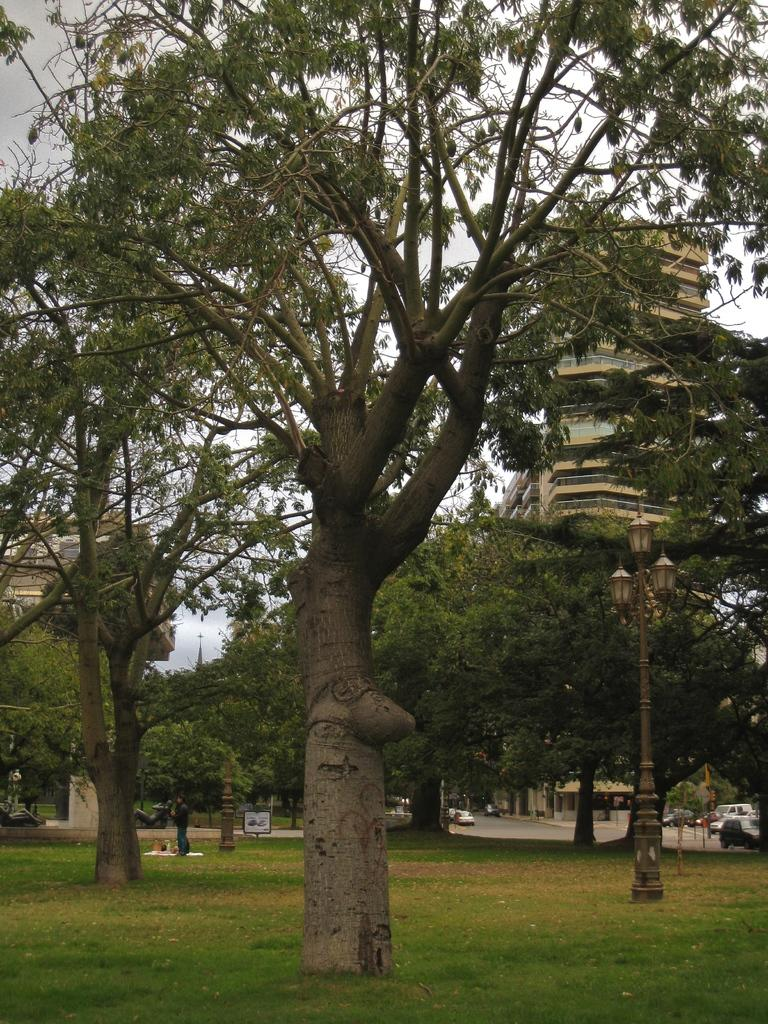What type of vegetation can be seen in the image? There is grass in the image. What other natural elements are present in the image? There are trees in the image. What type of man-made structures are visible in the image? There are buildings in the image. What type of lighting is present in the image? There is a street lamp in the image. What type of transportation is visible in the image? There are vehicles in the image. What is visible at the top of the image? The sky is visible at the top of the image. How many pies are being baked on the ground in the image? There are no pies or baking activity present in the image. What type of slope can be seen in the image? There is no slope visible in the image; it features a flat landscape with grass, trees, buildings, a street lamp, vehicles, and the sky. 